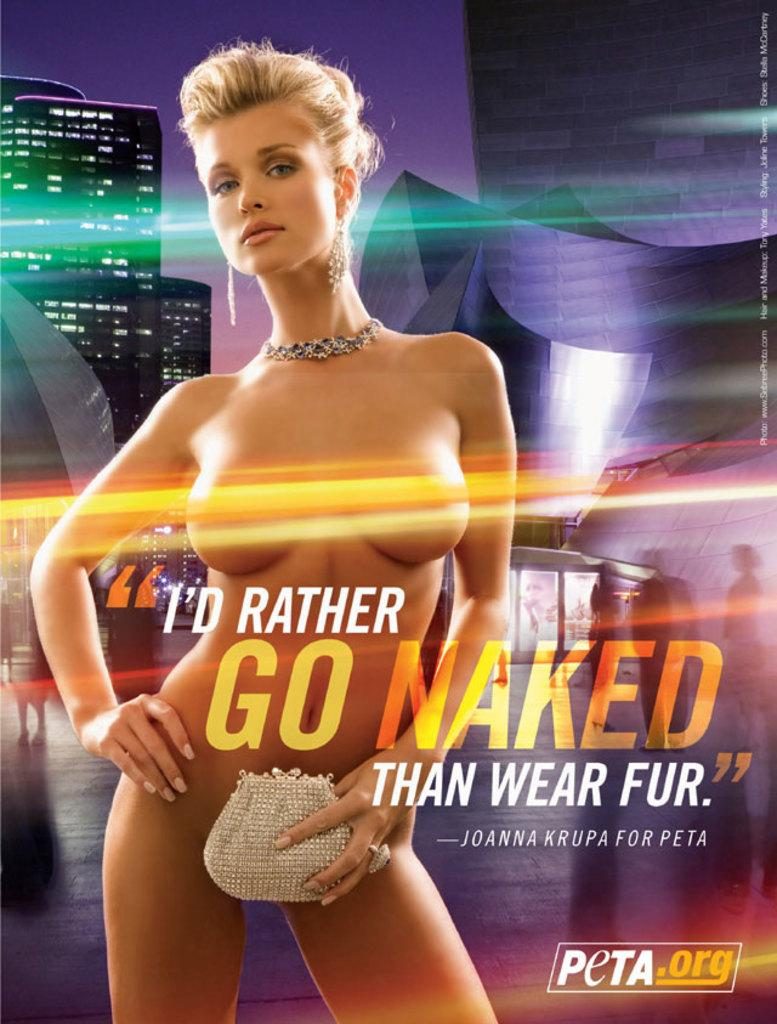<image>
Describe the image concisely. An advertisement for Peta featuring Joanna Krupa saying "I'd rather go naked than wear fur." 